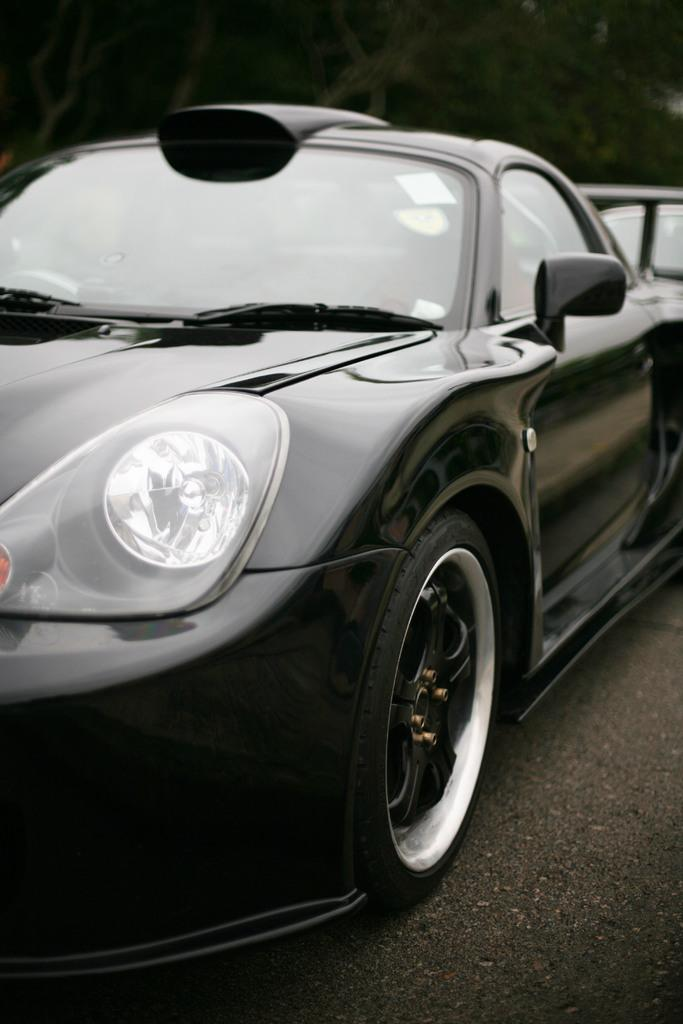What color is the car in the image? The car in the image is black. What is located at the bottom of the image? There is a road at the bottom of the image. How would you describe the background of the image? The background of the image is blurred. Where are the frogs hiding in the image? There are no frogs present in the image. What type of trousers is the driver of the car wearing? There is no driver visible in the image, and therefore no trousers can be observed. 